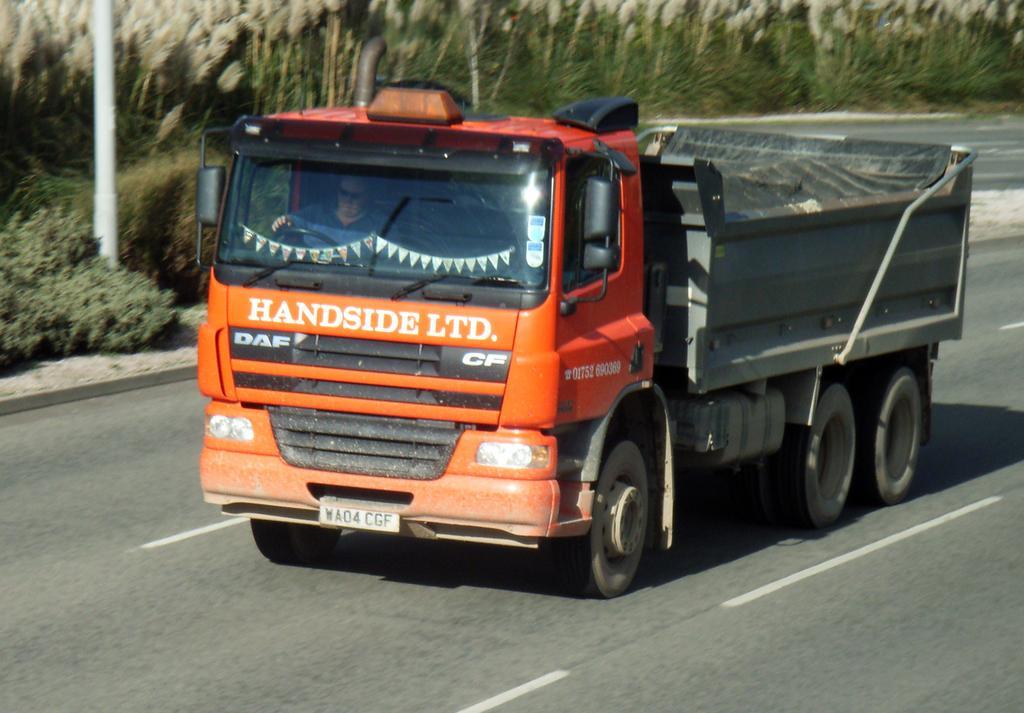Can you describe this image briefly? In the center of the image a truck is there. In truck a man is sitting. In the background of the image we can see some trees, pole, plants are there. At the bottom of the image road is there. 